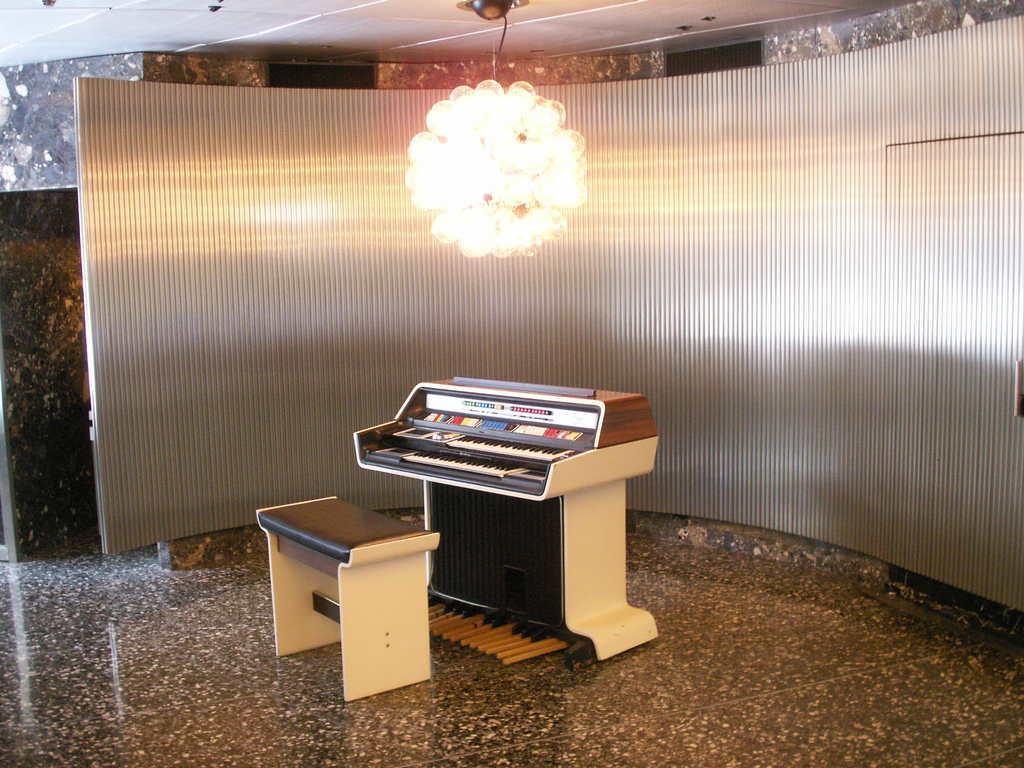Describe this image in one or two sentences. In the picture there is a piano in front of that there is a table to sit, behind that there is a metal wall ,to the roof there is a falling light in the background there is a marble wall. 